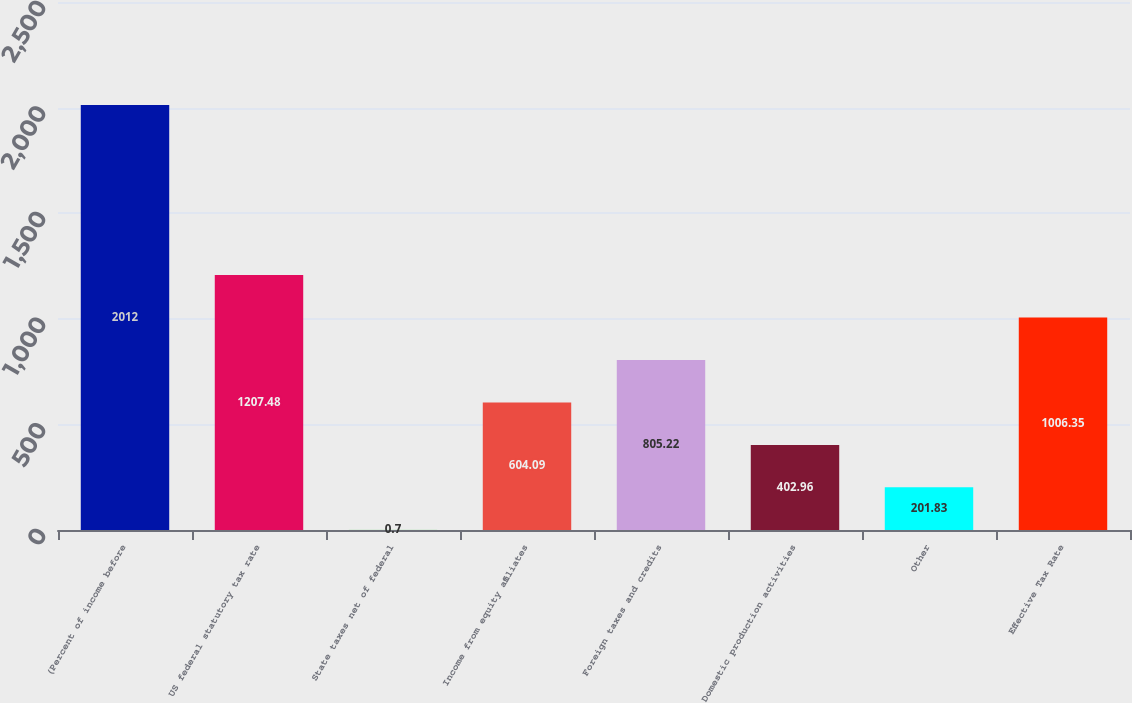Convert chart to OTSL. <chart><loc_0><loc_0><loc_500><loc_500><bar_chart><fcel>(Percent of income before<fcel>US federal statutory tax rate<fcel>State taxes net of federal<fcel>Income from equity affiliates<fcel>Foreign taxes and credits<fcel>Domestic production activities<fcel>Other<fcel>Effective Tax Rate<nl><fcel>2012<fcel>1207.48<fcel>0.7<fcel>604.09<fcel>805.22<fcel>402.96<fcel>201.83<fcel>1006.35<nl></chart> 